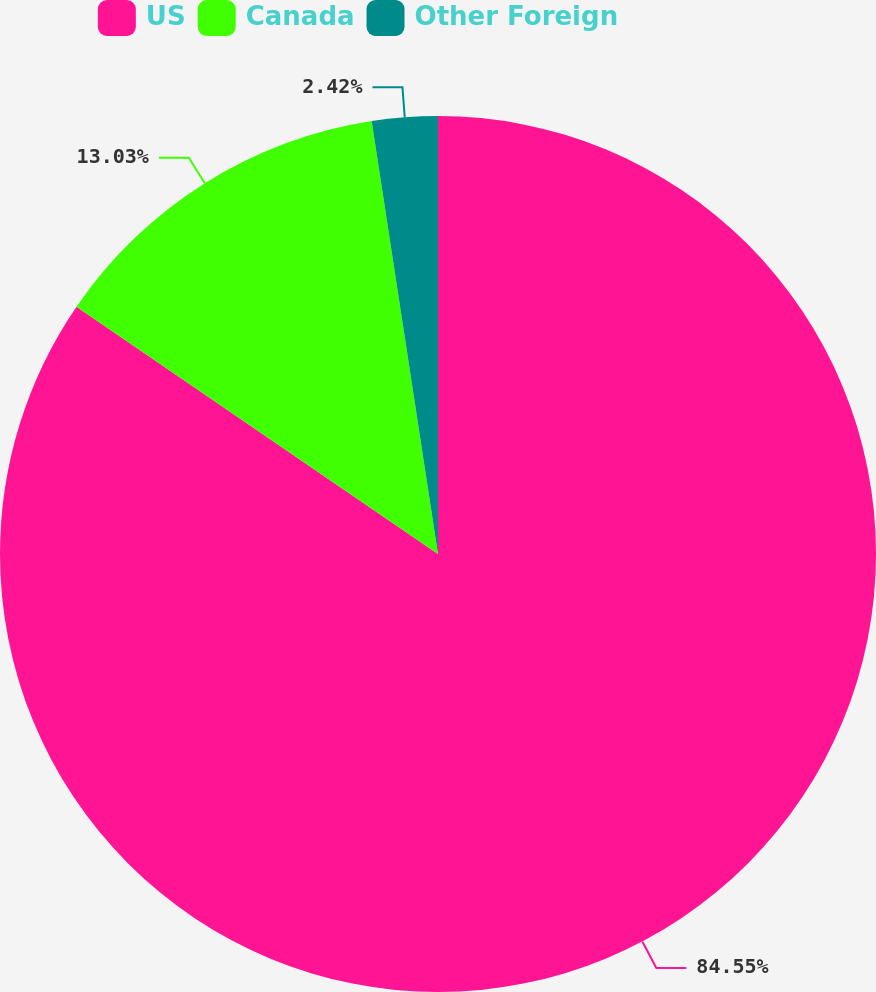Convert chart to OTSL. <chart><loc_0><loc_0><loc_500><loc_500><pie_chart><fcel>US<fcel>Canada<fcel>Other Foreign<nl><fcel>84.55%<fcel>13.03%<fcel>2.42%<nl></chart> 